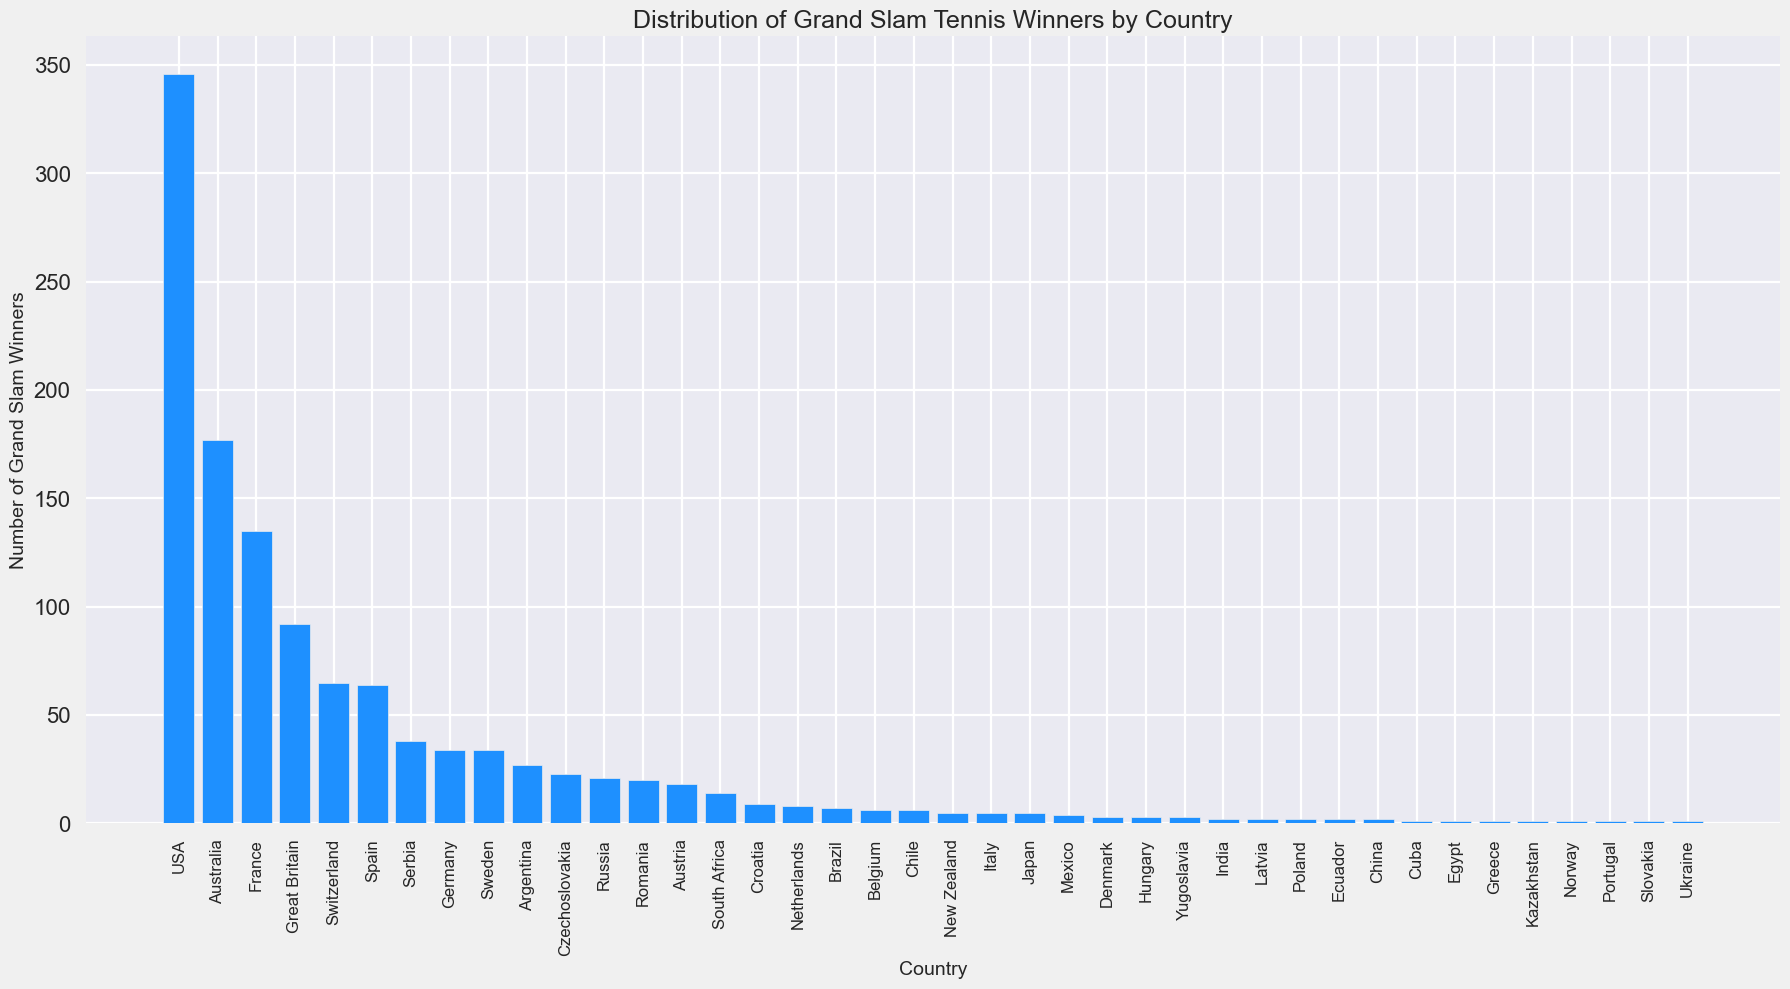which country has the highest number of Grand Slam winners? By looking at the height of the bars, the USA has the highest bar, representing the highest number of Grand Slam winners.
Answer: USA which two countries combined have less Grand Slam winners than Australia? Australia has 177 winners. France and Great Britain together have fewer than 177 since France has 135 and Great Britain has 92. Adding them up gives 135 + 92 = 227, which is more than 177. However, Switzerland (65) and Spain (64) together have 65 + 64 = 129, which is fewer than 177.
Answer: Switzerland and Spain which country has more Grand Slam winners, Serbia or Germany? By comparing the height of the bars, we see that Serbia's bar is slightly higher than Germany's. Serbia has 38 winners while Germany has 34.
Answer: Serbia how many Grand Slam winners does Italy have? By looking at the height of Italy's bar and the labels, Italy has 5 Grand Slam winners.
Answer: 5 which country has the lowest number of Grand Slam winners? By checking the country with the shortest bar and the smallest value label, 1, several countries fall into this category: Cuba, Egypt, Greece, Kazakhstan, Norway, Portugal, Slovakia, and Ukraine.
Answer: Cuba, Egypt, Greece, Kazakhstan, Norway, Portugal, Slovakia, Ukraine 